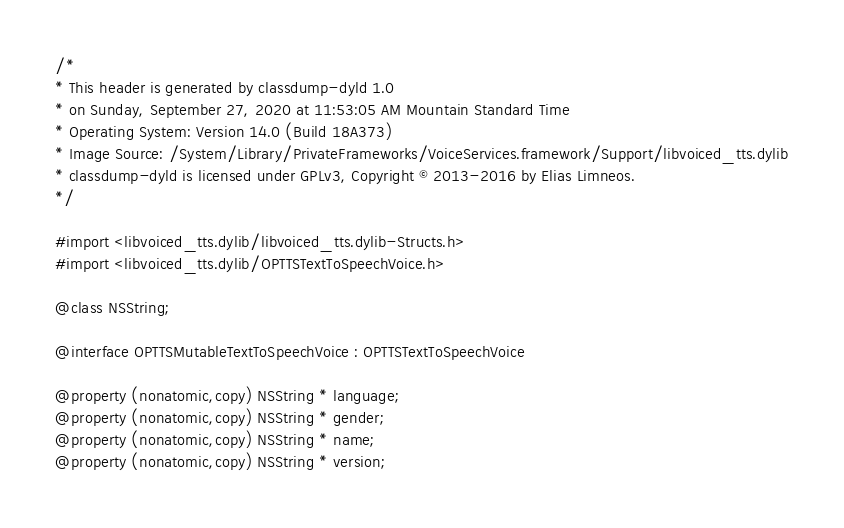<code> <loc_0><loc_0><loc_500><loc_500><_C_>/*
* This header is generated by classdump-dyld 1.0
* on Sunday, September 27, 2020 at 11:53:05 AM Mountain Standard Time
* Operating System: Version 14.0 (Build 18A373)
* Image Source: /System/Library/PrivateFrameworks/VoiceServices.framework/Support/libvoiced_tts.dylib
* classdump-dyld is licensed under GPLv3, Copyright © 2013-2016 by Elias Limneos.
*/

#import <libvoiced_tts.dylib/libvoiced_tts.dylib-Structs.h>
#import <libvoiced_tts.dylib/OPTTSTextToSpeechVoice.h>

@class NSString;

@interface OPTTSMutableTextToSpeechVoice : OPTTSTextToSpeechVoice

@property (nonatomic,copy) NSString * language; 
@property (nonatomic,copy) NSString * gender; 
@property (nonatomic,copy) NSString * name; 
@property (nonatomic,copy) NSString * version; </code> 